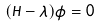Convert formula to latex. <formula><loc_0><loc_0><loc_500><loc_500>( H - \lambda ) \phi = 0</formula> 